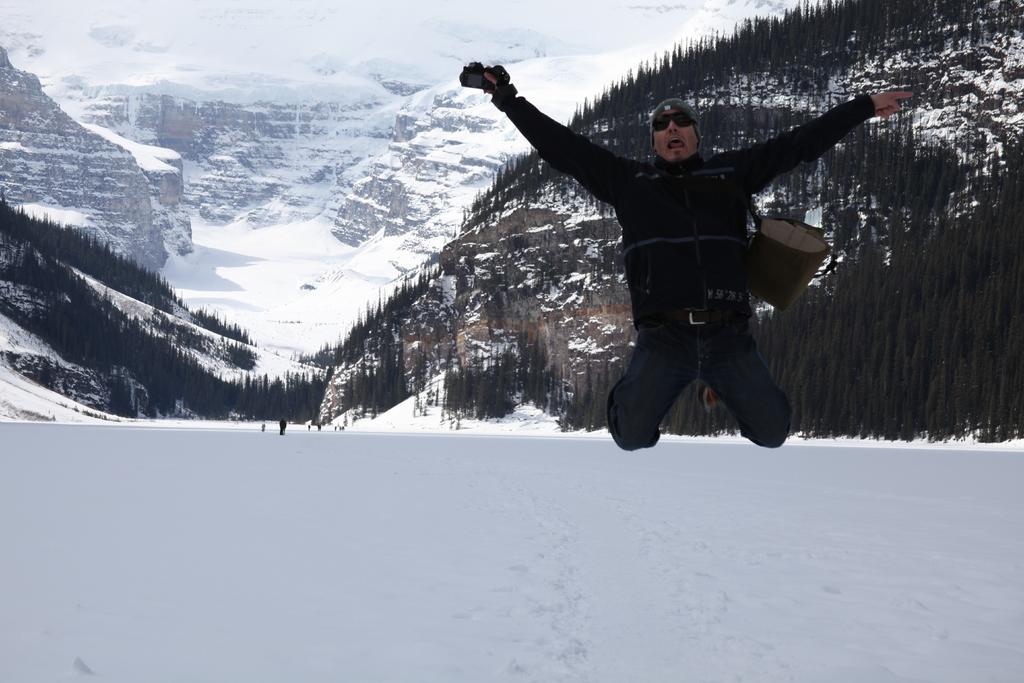Describe this image in one or two sentences. In the picture we can see a snow surface on it we can see a man jumping he is in a black jacket, cap and goggle and holding a bag and behind him we can see some people are standing and behind them we can see a hill with snow and trees and in the background also we can see hills covered with snow. 